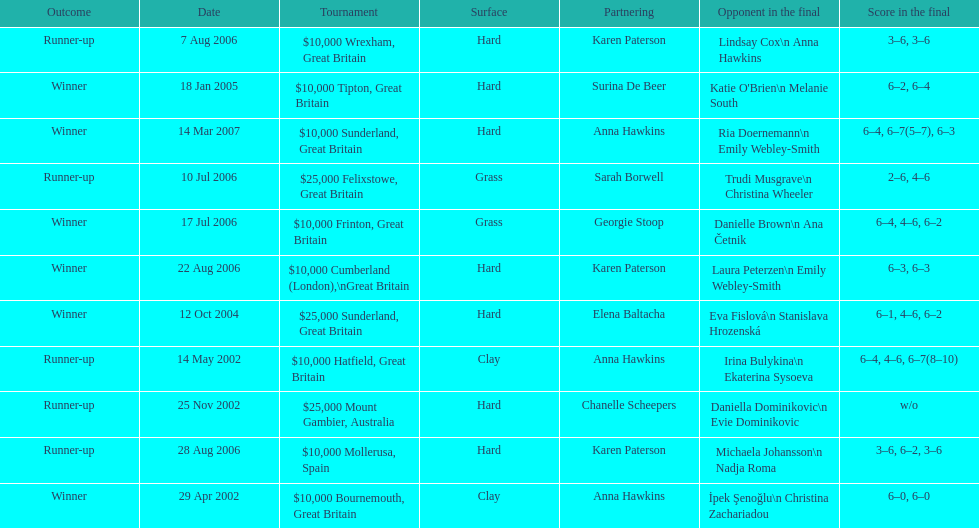How many tournaments has jane o'donoghue competed in? 11. 